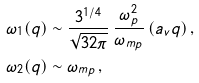<formula> <loc_0><loc_0><loc_500><loc_500>\omega _ { 1 } ( { q } ) & \sim \frac { 3 ^ { 1 / 4 } } { \sqrt { 3 2 \pi } } \, \frac { \omega _ { p } ^ { 2 } } { \omega _ { m p } } \, ( a _ { v } q ) \, , \\ \omega _ { 2 } ( { q } ) & \sim \omega _ { m p } \, ,</formula> 